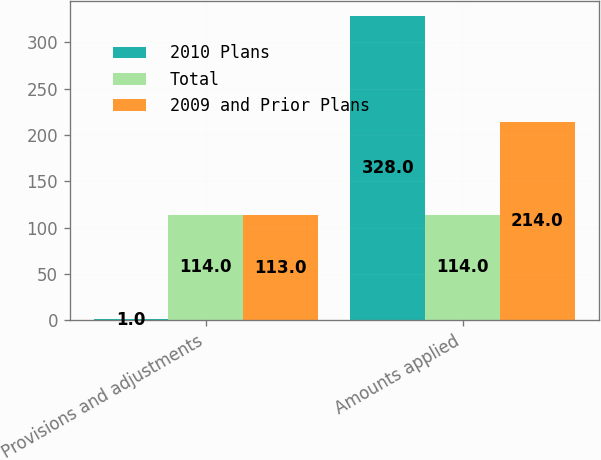Convert chart. <chart><loc_0><loc_0><loc_500><loc_500><stacked_bar_chart><ecel><fcel>Provisions and adjustments<fcel>Amounts applied<nl><fcel>2010 Plans<fcel>1<fcel>328<nl><fcel>Total<fcel>114<fcel>114<nl><fcel>2009 and Prior Plans<fcel>113<fcel>214<nl></chart> 